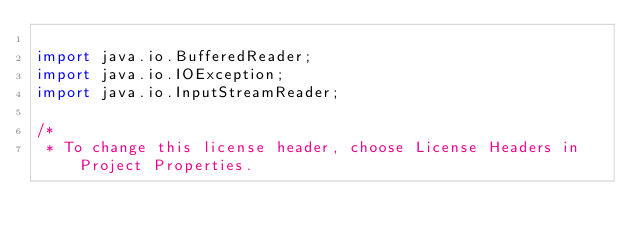<code> <loc_0><loc_0><loc_500><loc_500><_Java_>
import java.io.BufferedReader;
import java.io.IOException;
import java.io.InputStreamReader;

/*
 * To change this license header, choose License Headers in Project Properties.</code> 